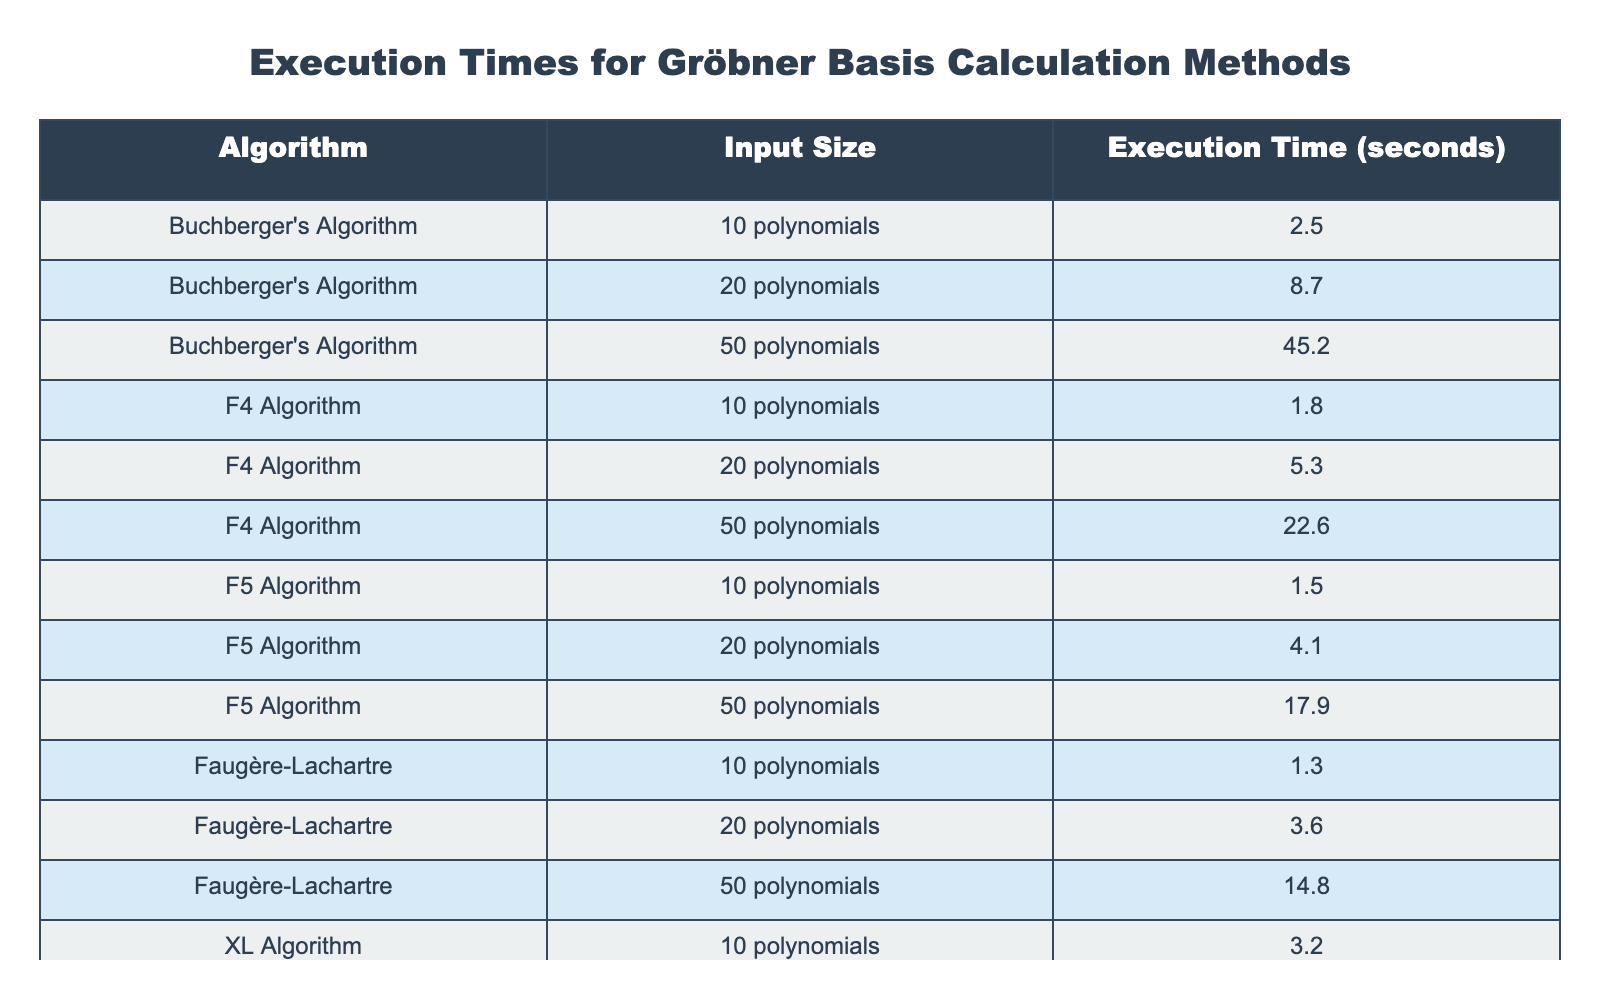What is the execution time for Buchberger's Algorithm with 50 polynomials? The table indicates that the execution time for Buchberger's Algorithm with 50 polynomials is listed directly under "Execution Time (seconds)", which shows a value of 45.2 seconds.
Answer: 45.2 seconds Which algorithm has the shortest execution time for 10 polynomials? In the table, the execution times for 10 polynomials are listed for each algorithm. Faugère-Lachartre has the shortest execution time at 1.3 seconds, compared to F5 at 1.5 seconds, F4 at 1.8 seconds, and others.
Answer: Faugère-Lachartre What is the total execution time for the F4 Algorithm across all input sizes? To find the total execution time for the F4 Algorithm, we sum the execution times for each input size: 1.8 + 5.3 + 22.6 = 29.7 seconds. This summation gives the complete execution time for F4 across the three listed input sizes.
Answer: 29.7 seconds Is the execution time for the XL Algorithm with 20 polynomials greater than the execution time for the F5 Algorithm with 50 polynomials? The execution time for the XL Algorithm with 20 polynomials is 12.5 seconds, and for the F5 Algorithm with 50 polynomials, it is 17.9 seconds. Since 12.5 is less than 17.9, the XL Algorithm's execution time is not greater.
Answer: No Which algorithm has the largest difference in execution time between the input sizes of 10 and 50 polynomials? To find the largest difference, we calculate the execution time differences for each algorithm: 
- Buchberger's Algorithm: 45.2 - 2.5 = 42.7 
- F4 Algorithm: 22.6 - 1.8 = 20.8 
- F5 Algorithm: 17.9 - 1.5 = 16.4 
- Faugère-Lachartre: 14.8 - 1.3 = 13.5 
- XL Algorithm: 68.7 - 3.2 = 65.5 
The largest difference is 65.5 seconds for the XL Algorithm.
Answer: XL Algorithm What is the average execution time for Faugère-Lachartre across the three different input sizes? The execution times for Faugère-Lachartre are: 1.3 seconds, 3.6 seconds, and 14.8 seconds. We sum these values (1.3 + 3.6 + 14.8 = 19.7) and then divide by the number of input sizes (3) to find the average: 19.7 / 3 = 6.57 seconds.
Answer: 6.57 seconds 